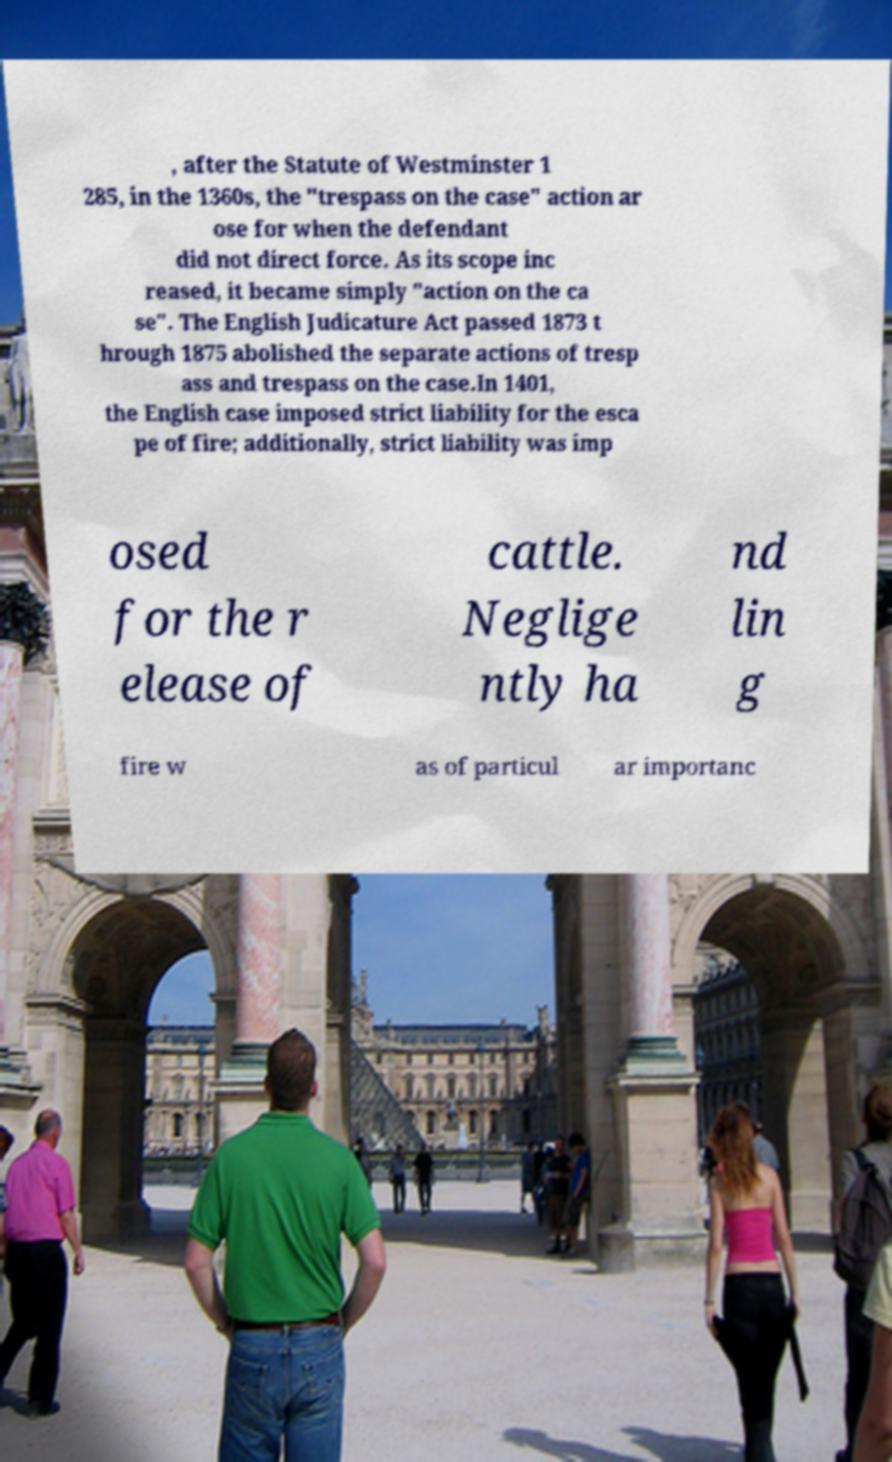What messages or text are displayed in this image? I need them in a readable, typed format. , after the Statute of Westminster 1 285, in the 1360s, the "trespass on the case" action ar ose for when the defendant did not direct force. As its scope inc reased, it became simply "action on the ca se". The English Judicature Act passed 1873 t hrough 1875 abolished the separate actions of tresp ass and trespass on the case.In 1401, the English case imposed strict liability for the esca pe of fire; additionally, strict liability was imp osed for the r elease of cattle. Neglige ntly ha nd lin g fire w as of particul ar importanc 